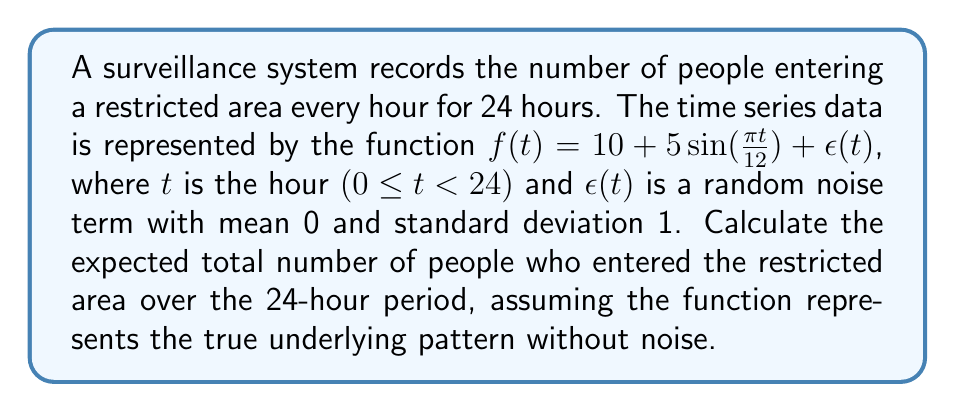Teach me how to tackle this problem. To solve this problem, we need to integrate the given function over the 24-hour period, excluding the noise term. The steps are as follows:

1) The function without noise is $f(t) = 10 + 5\sin(\frac{\pi t}{12})$

2) To find the total number of people, we need to integrate this function from 0 to 24:

   $$\int_0^{24} (10 + 5\sin(\frac{\pi t}{12})) dt$$

3) Let's break this into two parts:
   
   $$\int_0^{24} 10 dt + \int_0^{24} 5\sin(\frac{\pi t}{12}) dt$$

4) The first part is straightforward:
   
   $$\int_0^{24} 10 dt = 10t \Big|_0^{24} = 10 \cdot 24 - 10 \cdot 0 = 240$$

5) For the second part, we can use the substitution method. Let $u = \frac{\pi t}{12}$, then $du = \frac{\pi}{12} dt$ or $dt = \frac{12}{\pi} du$

   When $t = 0$, $u = 0$
   When $t = 24$, $u = 2\pi$

   So, the integral becomes:

   $$5 \int_0^{2\pi} \sin(u) \cdot \frac{12}{\pi} du = \frac{60}{\pi} \int_0^{2\pi} \sin(u) du$$

6) We know that $\int \sin(u) du = -\cos(u) + C$, so:

   $$\frac{60}{\pi} [-\cos(u)]_0^{2\pi} = \frac{60}{\pi} [-\cos(2\pi) + \cos(0)] = \frac{60}{\pi} [-(1) + 1] = 0$$

7) Adding the results from steps 4 and 6:

   $$240 + 0 = 240$$

Thus, the expected total number of people entering the restricted area over the 24-hour period is 240.
Answer: 240 people 